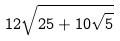<formula> <loc_0><loc_0><loc_500><loc_500>1 2 \sqrt { 2 5 + 1 0 \sqrt { 5 } }</formula> 